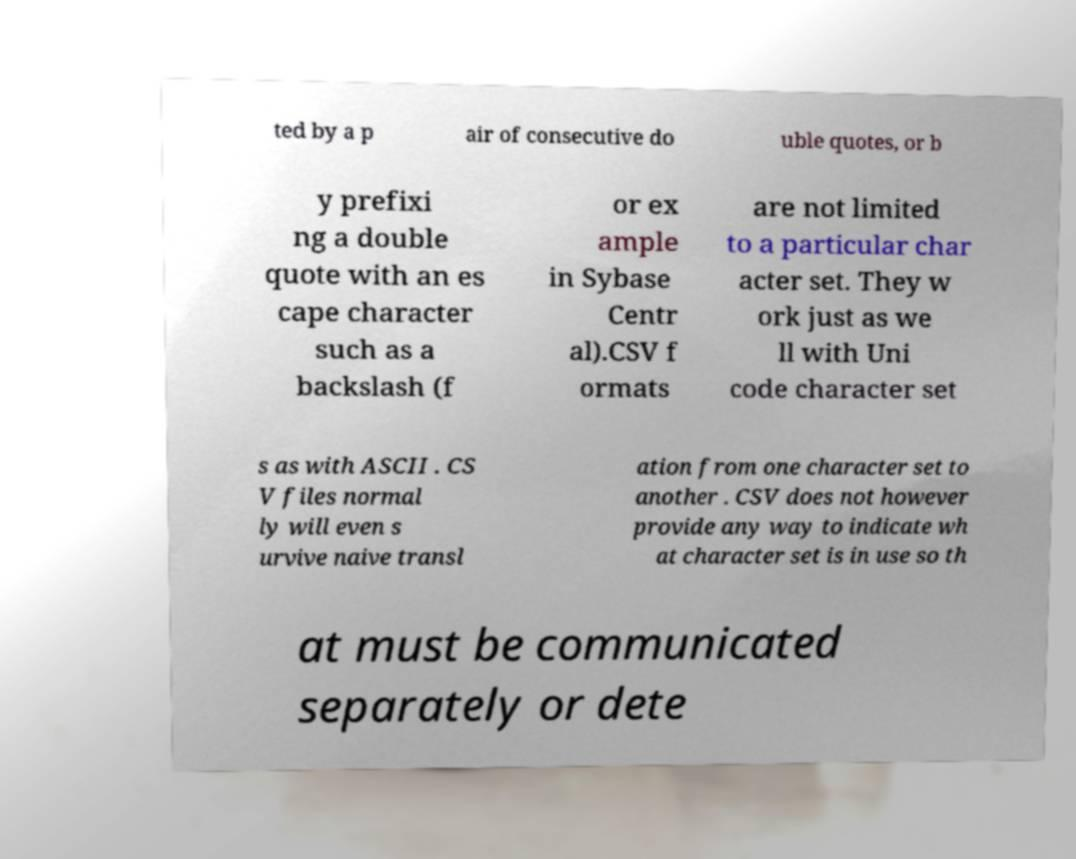Please read and relay the text visible in this image. What does it say? ted by a p air of consecutive do uble quotes, or b y prefixi ng a double quote with an es cape character such as a backslash (f or ex ample in Sybase Centr al).CSV f ormats are not limited to a particular char acter set. They w ork just as we ll with Uni code character set s as with ASCII . CS V files normal ly will even s urvive naive transl ation from one character set to another . CSV does not however provide any way to indicate wh at character set is in use so th at must be communicated separately or dete 